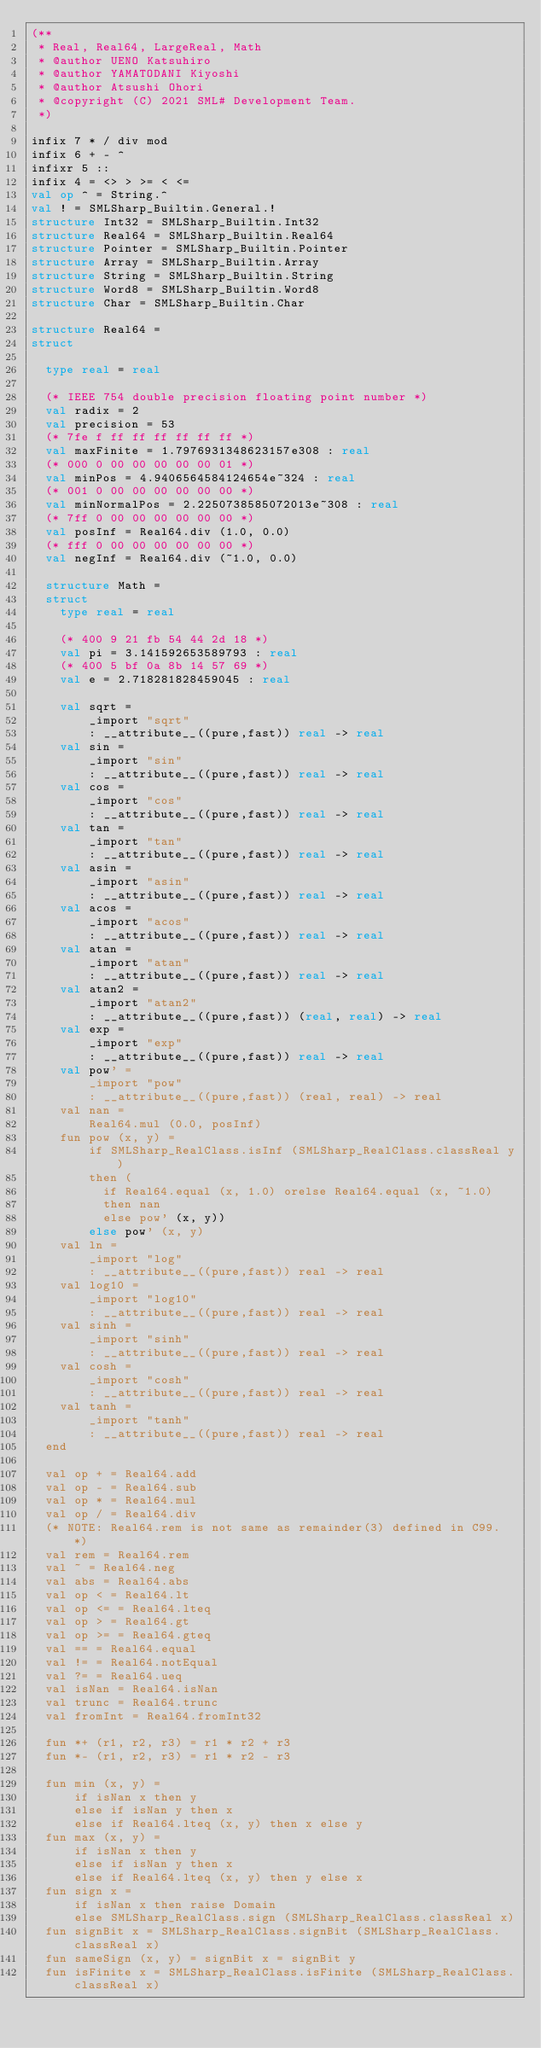Convert code to text. <code><loc_0><loc_0><loc_500><loc_500><_SML_>(**
 * Real, Real64, LargeReal, Math
 * @author UENO Katsuhiro
 * @author YAMATODANI Kiyoshi
 * @author Atsushi Ohori
 * @copyright (C) 2021 SML# Development Team.
 *)

infix 7 * / div mod
infix 6 + - ^
infixr 5 ::
infix 4 = <> > >= < <=
val op ^ = String.^
val ! = SMLSharp_Builtin.General.!
structure Int32 = SMLSharp_Builtin.Int32
structure Real64 = SMLSharp_Builtin.Real64
structure Pointer = SMLSharp_Builtin.Pointer
structure Array = SMLSharp_Builtin.Array
structure String = SMLSharp_Builtin.String
structure Word8 = SMLSharp_Builtin.Word8
structure Char = SMLSharp_Builtin.Char

structure Real64 =
struct

  type real = real

  (* IEEE 754 double precision floating point number *)
  val radix = 2
  val precision = 53
  (* 7fe f ff ff ff ff ff ff *)
  val maxFinite = 1.7976931348623157e308 : real
  (* 000 0 00 00 00 00 00 01 *)
  val minPos = 4.9406564584124654e~324 : real
  (* 001 0 00 00 00 00 00 00 *)
  val minNormalPos = 2.2250738585072013e~308 : real
  (* 7ff 0 00 00 00 00 00 00 *)
  val posInf = Real64.div (1.0, 0.0)
  (* fff 0 00 00 00 00 00 00 *)
  val negInf = Real64.div (~1.0, 0.0)

  structure Math =
  struct
    type real = real

    (* 400 9 21 fb 54 44 2d 18 *)
    val pi = 3.141592653589793 : real
    (* 400 5 bf 0a 8b 14 57 69 *)
    val e = 2.718281828459045 : real

    val sqrt =
        _import "sqrt"
        : __attribute__((pure,fast)) real -> real
    val sin =
        _import "sin"
        : __attribute__((pure,fast)) real -> real
    val cos =
        _import "cos"
        : __attribute__((pure,fast)) real -> real
    val tan =
        _import "tan"
        : __attribute__((pure,fast)) real -> real
    val asin =
        _import "asin"
        : __attribute__((pure,fast)) real -> real
    val acos =
        _import "acos"
        : __attribute__((pure,fast)) real -> real
    val atan =
        _import "atan"
        : __attribute__((pure,fast)) real -> real
    val atan2 =
        _import "atan2"
        : __attribute__((pure,fast)) (real, real) -> real
    val exp =
        _import "exp"
        : __attribute__((pure,fast)) real -> real
    val pow' =
        _import "pow"
        : __attribute__((pure,fast)) (real, real) -> real
    val nan =
        Real64.mul (0.0, posInf)
    fun pow (x, y) =
        if SMLSharp_RealClass.isInf (SMLSharp_RealClass.classReal y)
        then (
          if Real64.equal (x, 1.0) orelse Real64.equal (x, ~1.0)
          then nan
          else pow' (x, y))
        else pow' (x, y)
    val ln =
        _import "log"
        : __attribute__((pure,fast)) real -> real
    val log10 =
        _import "log10"
        : __attribute__((pure,fast)) real -> real
    val sinh =
        _import "sinh"
        : __attribute__((pure,fast)) real -> real
    val cosh =
        _import "cosh"
        : __attribute__((pure,fast)) real -> real
    val tanh =
        _import "tanh"
        : __attribute__((pure,fast)) real -> real
  end

  val op + = Real64.add
  val op - = Real64.sub
  val op * = Real64.mul
  val op / = Real64.div
  (* NOTE: Real64.rem is not same as remainder(3) defined in C99. *)
  val rem = Real64.rem
  val ~ = Real64.neg
  val abs = Real64.abs
  val op < = Real64.lt
  val op <= = Real64.lteq
  val op > = Real64.gt
  val op >= = Real64.gteq
  val == = Real64.equal
  val != = Real64.notEqual
  val ?= = Real64.ueq
  val isNan = Real64.isNan
  val trunc = Real64.trunc
  val fromInt = Real64.fromInt32

  fun *+ (r1, r2, r3) = r1 * r2 + r3
  fun *- (r1, r2, r3) = r1 * r2 - r3

  fun min (x, y) =
      if isNan x then y
      else if isNan y then x
      else if Real64.lteq (x, y) then x else y
  fun max (x, y) =
      if isNan x then y
      else if isNan y then x
      else if Real64.lteq (x, y) then y else x
  fun sign x =
      if isNan x then raise Domain
      else SMLSharp_RealClass.sign (SMLSharp_RealClass.classReal x)
  fun signBit x = SMLSharp_RealClass.signBit (SMLSharp_RealClass.classReal x)
  fun sameSign (x, y) = signBit x = signBit y
  fun isFinite x = SMLSharp_RealClass.isFinite (SMLSharp_RealClass.classReal x)</code> 